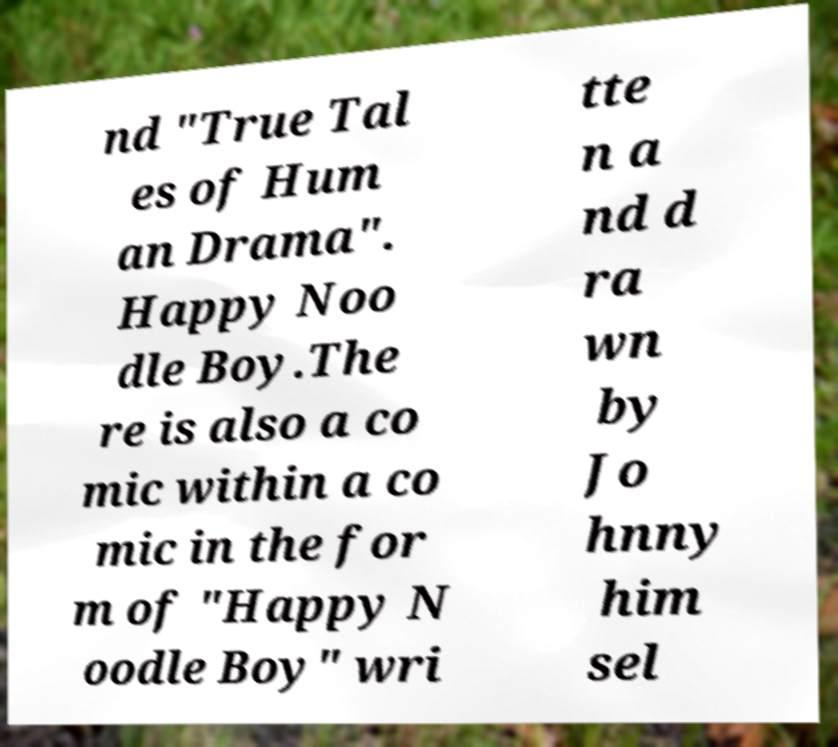Can you accurately transcribe the text from the provided image for me? nd "True Tal es of Hum an Drama". Happy Noo dle Boy.The re is also a co mic within a co mic in the for m of "Happy N oodle Boy" wri tte n a nd d ra wn by Jo hnny him sel 